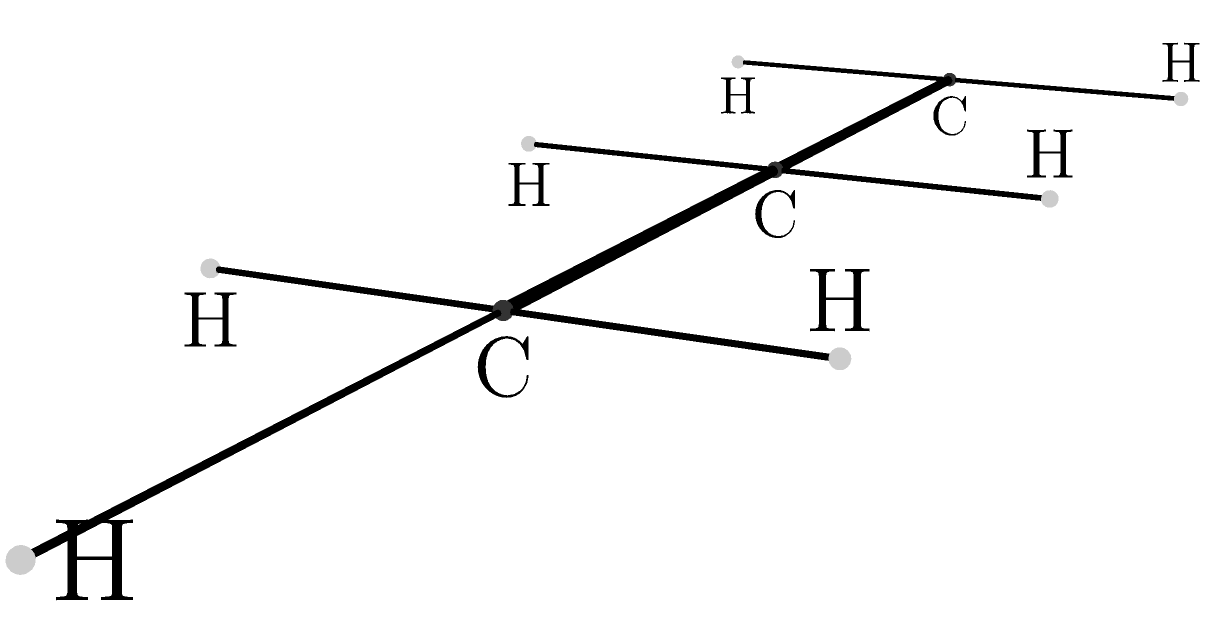Based on the ball-and-stick model shown above, which represents a common synthetic polymer, what is the chemical formula of the repeating unit? Express your answer in the form $C_xH_y$. To determine the chemical formula of the repeating unit, we need to analyze the ball-and-stick model:

1. Identify the atoms:
   - Larger, darker spheres represent carbon (C) atoms
   - Smaller, lighter spheres represent hydrogen (H) atoms

2. Count the number of carbon atoms in the repeating unit:
   - There are 3 carbon atoms in the main chain

3. Count the number of hydrogen atoms attached to each carbon:
   - The first and second carbon atoms each have 2 hydrogen atoms
   - The third carbon atom has 3 hydrogen atoms

4. Calculate the total number of hydrogen atoms:
   - Total H = 2 + 2 + 3 = 7

5. Express the formula:
   - The repeating unit contains 3 carbon atoms and 7 hydrogen atoms

Therefore, the chemical formula of the repeating unit is $C_3H_7$.
Answer: $C_3H_7$ 